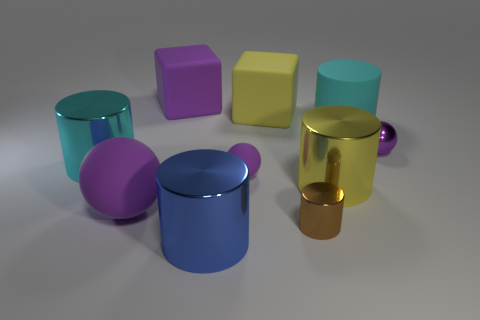Subtract all yellow cylinders. How many cylinders are left? 4 Subtract all cyan matte cylinders. How many cylinders are left? 4 Subtract all gray cylinders. Subtract all red balls. How many cylinders are left? 5 Subtract all balls. How many objects are left? 7 Add 1 large cyan cylinders. How many large cyan cylinders are left? 3 Add 6 big purple spheres. How many big purple spheres exist? 7 Subtract 0 green balls. How many objects are left? 10 Subtract all purple balls. Subtract all cyan cylinders. How many objects are left? 5 